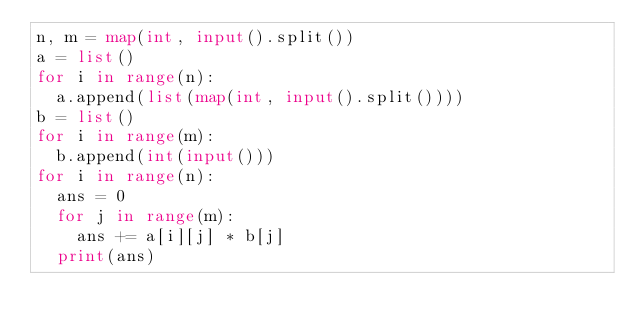Convert code to text. <code><loc_0><loc_0><loc_500><loc_500><_Python_>n, m = map(int, input().split())
a = list()
for i in range(n):
	a.append(list(map(int, input().split())))
b = list()
for i in range(m):
	b.append(int(input()))
for i in range(n):
	ans = 0
	for j in range(m):
		ans += a[i][j] * b[j]
	print(ans)
</code> 